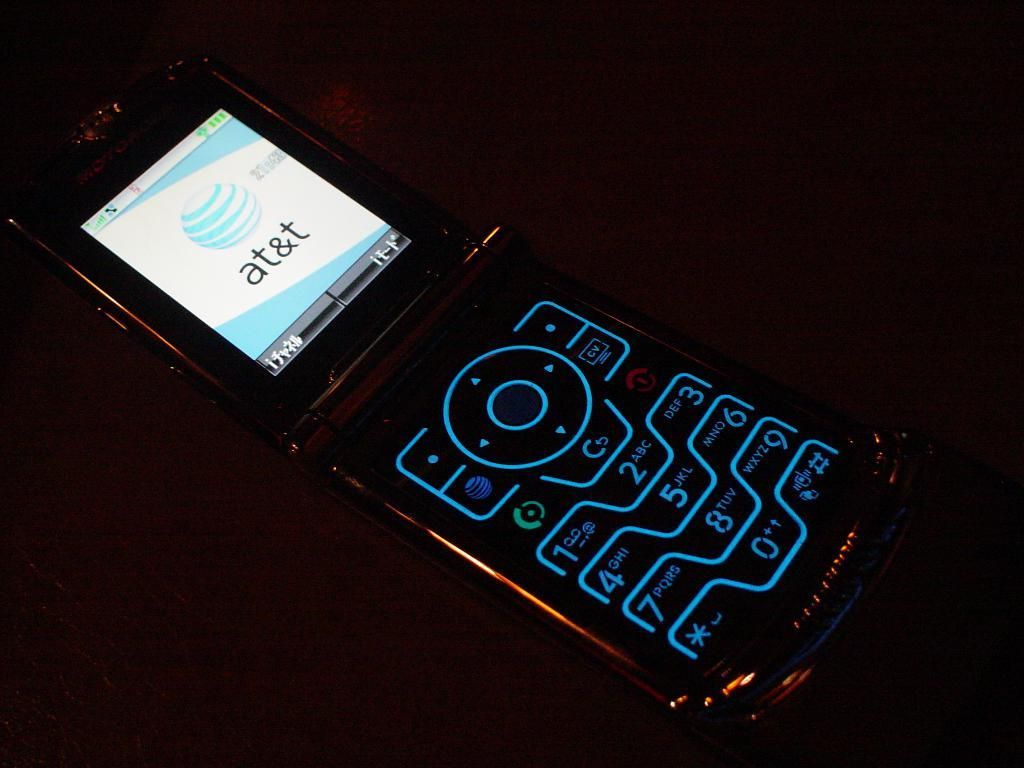Provide a one-sentence caption for the provided image. A flip phone is lit with bluish tint and the screen says AT&T. 